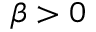<formula> <loc_0><loc_0><loc_500><loc_500>\beta > 0</formula> 